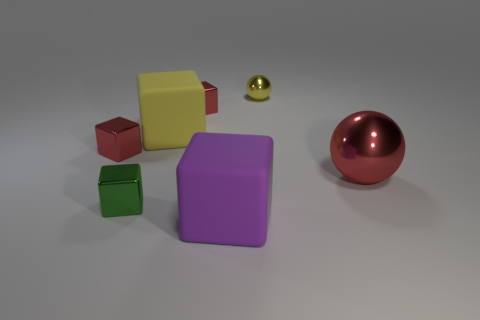Subtract all green cubes. How many cubes are left? 4 Subtract all small red shiny cubes. How many cubes are left? 3 Subtract all blue spheres. How many red blocks are left? 2 Add 2 gray matte balls. How many objects exist? 9 Subtract all yellow cubes. Subtract all green cylinders. How many cubes are left? 4 Subtract all balls. How many objects are left? 5 Add 5 big metallic spheres. How many big metallic spheres exist? 6 Subtract 1 green cubes. How many objects are left? 6 Subtract all big red shiny things. Subtract all tiny yellow shiny objects. How many objects are left? 5 Add 6 big purple matte cubes. How many big purple matte cubes are left? 7 